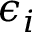Convert formula to latex. <formula><loc_0><loc_0><loc_500><loc_500>\epsilon _ { i }</formula> 